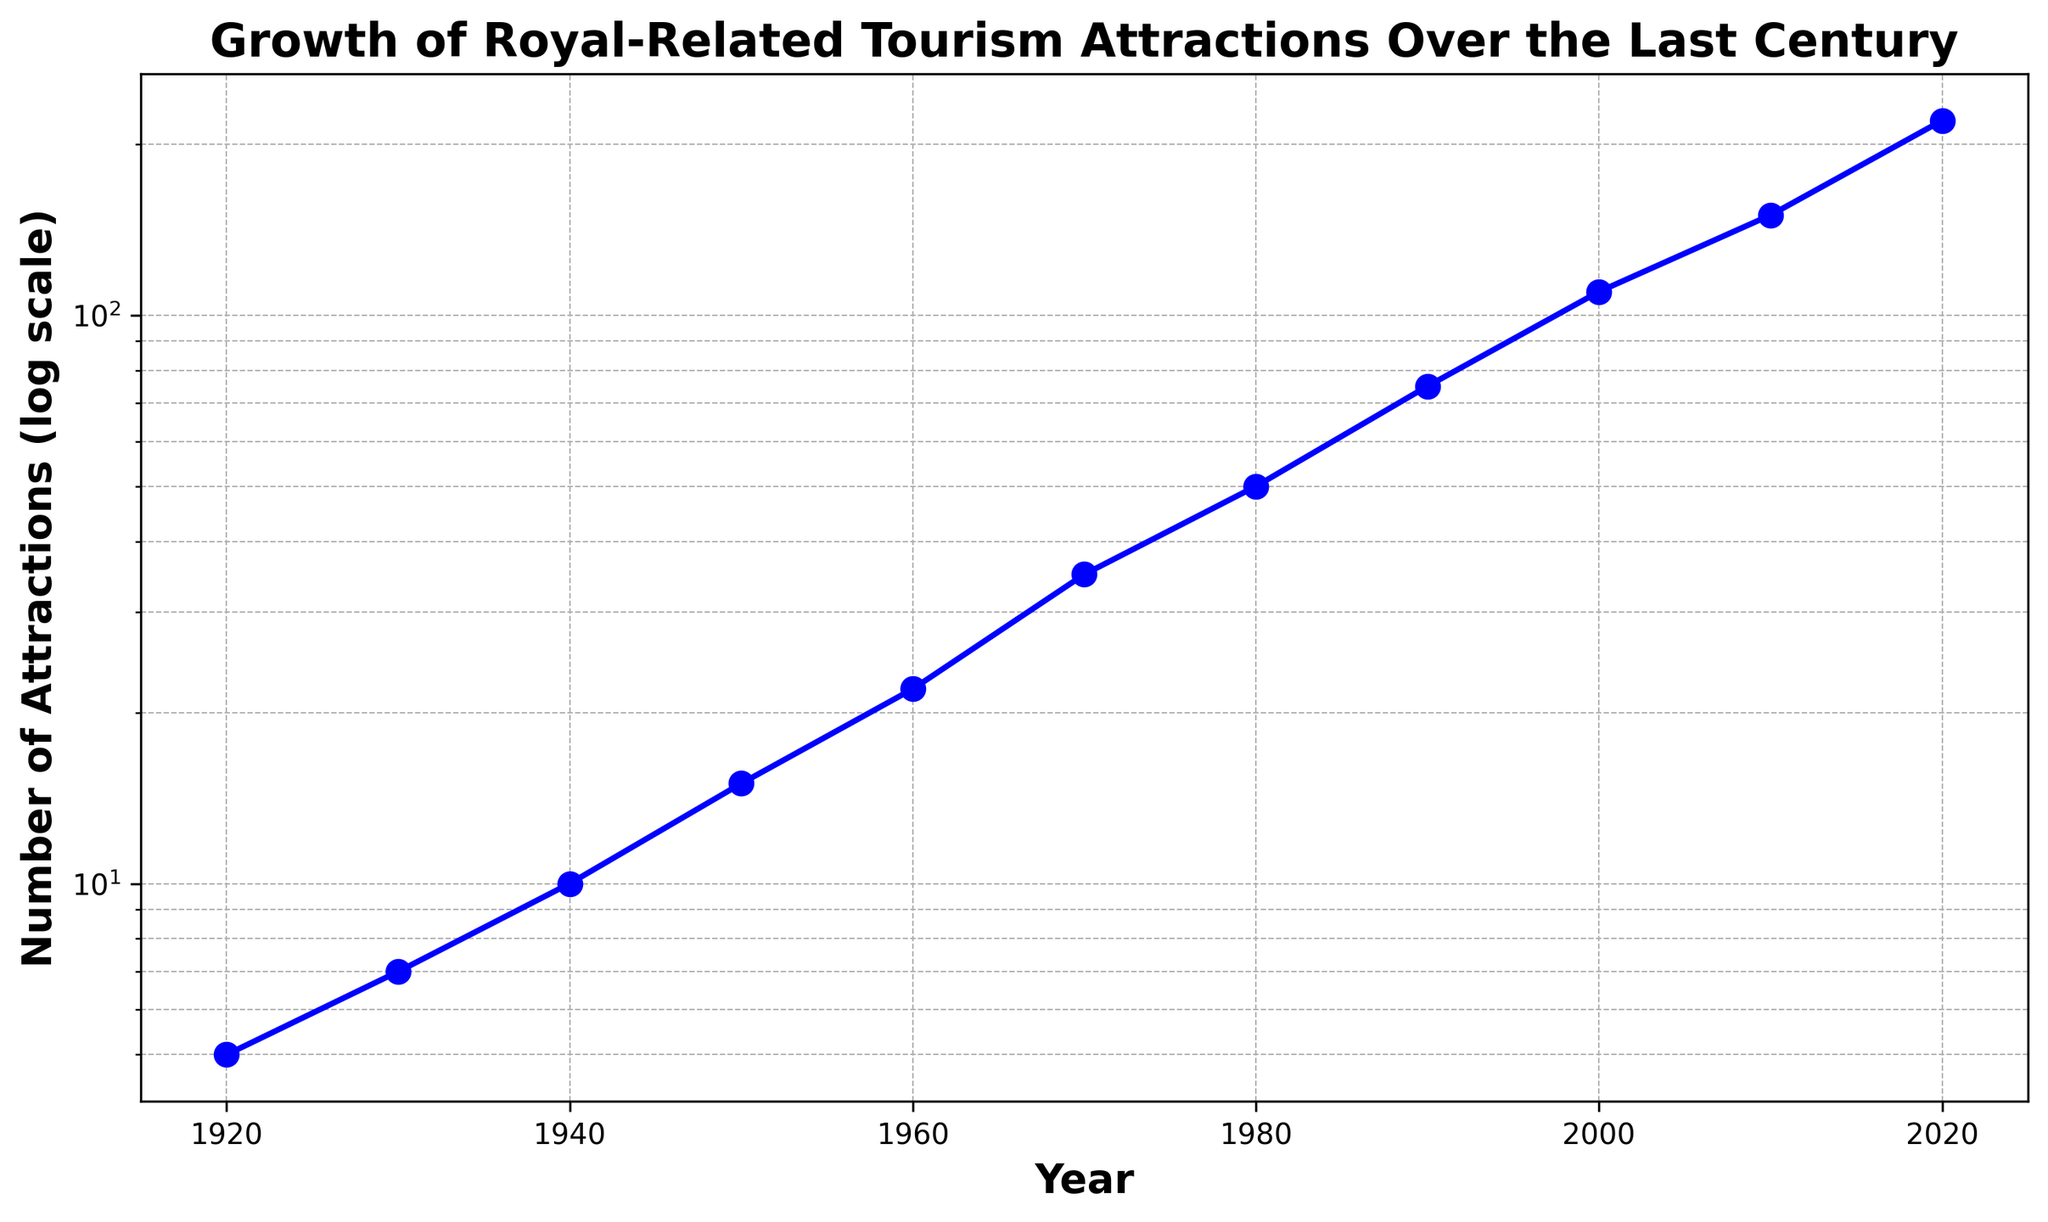What's the ratio of the number of royal-related tourism attractions in 2020 to 1920? In 2020, there are 220 attractions, and in 1920, there are 5 attractions. The ratio is calculated as 220 / 5 = 44
Answer: 44 Between which consecutive decades did the number of attractions increase the most? Look at each decade and calculate the difference: 1930-1920 (7-5=2), 1940-1930 (10-7=3), 1950-1940 (15-10=5), 1960-1950 (22-15=7), 1970-1960 (35-22=13), 1980-1970 (50-35=15), 1990-1980 (75-50=25), 2000-1990 (110-75=35), 2010-2000 (150-110=40), 2020-2010 (220-150=70). The increase is the most between 2010 and 2020 (70)
Answer: 2010-2020 What is the percent increase in the number of attractions from 1950 to 2000? In 1950, there are 15 attractions, and in 2000, there are 110. The percent increase is calculated as ((110 - 15) / 15) * 100 = 633.33%
Answer: 633.33% By how many attractions did the number increase every decade on average? Sum the decadal differences: (2 + 3 + 5 + 7 + 13 + 15 + 25 + 35 + 40 + 70) = 215. 215 / 10 = 21.5 attractions per decade on average
Answer: 21.5 During which decade did the number of attractions first exceed 50? In 1980, the number of attractions is 50.5 and only reaches 75 in 1990. Thus, the threshold of 50 is exceeded in the 1980 decade
Answer: 1980 What trend is illustrated by the length of decade intervals on the y-axis? Examine the spacing between points on the y-axis; the intervals show a logarithmic scale, indicating exponential growth
Answer: Exponential growth How many years did it take for the attractions to increase from 50 to 150? Identify the years when the attractions were 50 (1980) and 150 (2010), then calculate the difference: 2010 - 1980 = 30 years
Answer: 30 What can be said about the slope of the line on the plot? The line's slope appears to increase over decades, indicating a steeper rate of growth, particularly from 1990 onwards
Answer: Increasing At what year is the midpoint (in log scale terms) of the attractions' growth observed? The midpoint on a log scale graph is related to the geometry of the points but intuitively is around the 1960s given the exponential trend. Exact midpoint visual inspection places it around 1970
Answer: Approximately 1970 